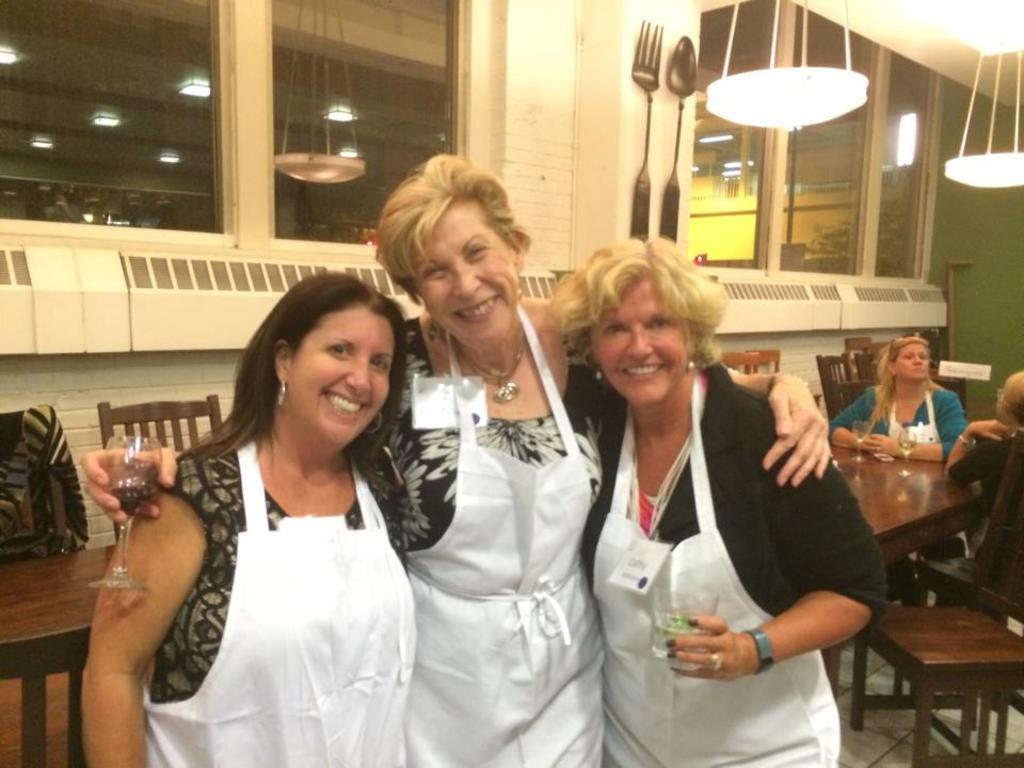In one or two sentences, can you explain what this image depicts? In this image we can see people standing on the floor by holding beverage tumblers in their hands. In the background there are people sitting on the chairs and tables are placed in front of them. On the tables there are glass tumblers. In addition to this we can see electric lights, decors and walls. 